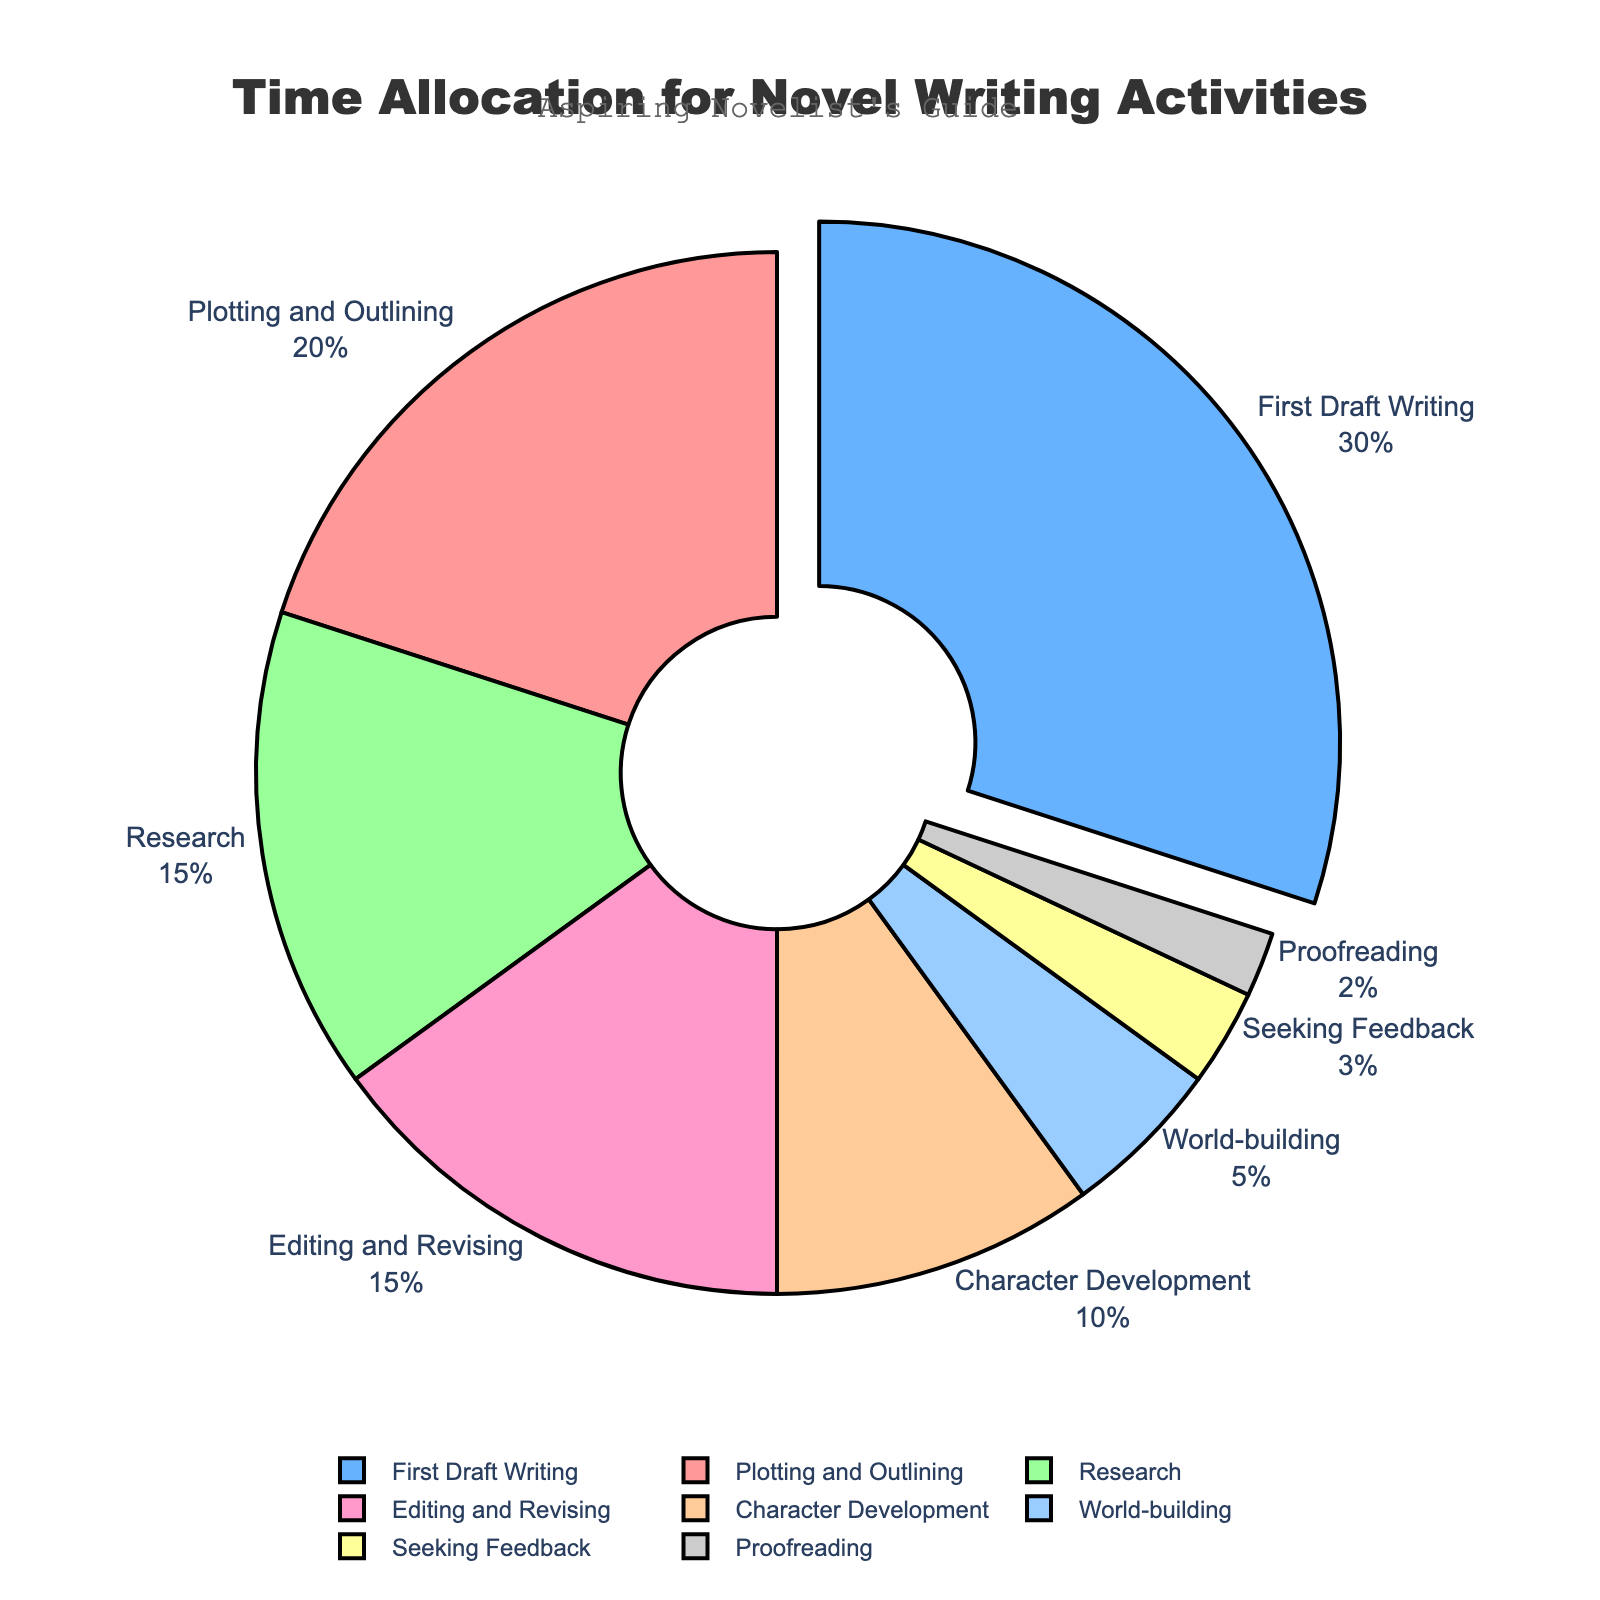What's the activity with the highest time allocation? The largest portion of the pie chart will represent the activity with the highest percentage. Here, the "First Draft Writing" slice is largest and also highlighted by being pulled out slightly.
Answer: First Draft Writing Which activity has the second lowest time allocation? To determine the second lowest, identify the smallest portion first, which is "Proofreading" at 2%. The next smallest portion after that is "Seeking Feedback" at 3%.
Answer: Seeking Feedback What's the combined percentage of time spent on "Character Development" and "World-building"? Identify the individual percentages for "Character Development" (10%) and "World-building" (5%) and then sum them up: 10% + 5% = 15%.
Answer: 15% Which activities together take up 50% of the total time allocation? Sum up the percentages of activities until you reach 50%. Start from the largest portion: "First Draft Writing" (30%) and then "Plotting and Outlining" (20%). 30% + 20% = 50%.
Answer: First Draft Writing and Plotting and Outlining How many more percentage points are allocated to "First Draft Writing" than to "Research"? Subtract the percentage of "Research" from "First Draft Writing": 30% (First Draft Writing) - 15% (Research) = 15%.
Answer: 15% Which color represents "Editing and Revising"? Look at the color of the slice labeled "Editing and Revising," which is represented by a pale pink color.
Answer: Pale Pink What is the difference in percentage points between the time allocated to "Editing and Revising" and "Research"? Subtract the percentage of "Research" from "Editing and Revising": 15% (Editing and Revising) - 15% (Research) = 0%.
Answer: 0% Are there more activities that individually take 15% of the time or less, than those that take more than 15%? Count the number of activities taking 15% or less: "Research" (15%), "Character Development" (10%), "Editing and Revising" (15%), "World-building" (5%), "Seeking Feedback" (3%), "Proofreading" (2%). That's 6 activities. Only two activities take more than 15%: "First Draft Writing" (30%) and "Plotting and Outlining" (20%).
Answer: Yes 